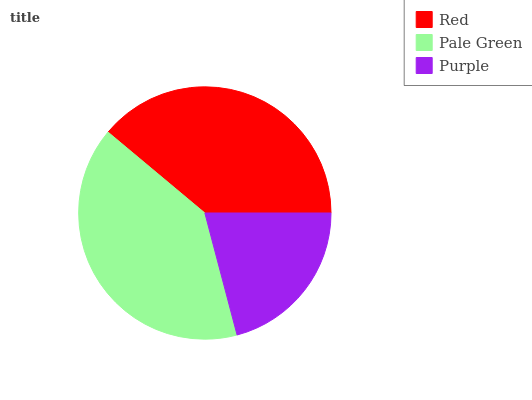Is Purple the minimum?
Answer yes or no. Yes. Is Pale Green the maximum?
Answer yes or no. Yes. Is Pale Green the minimum?
Answer yes or no. No. Is Purple the maximum?
Answer yes or no. No. Is Pale Green greater than Purple?
Answer yes or no. Yes. Is Purple less than Pale Green?
Answer yes or no. Yes. Is Purple greater than Pale Green?
Answer yes or no. No. Is Pale Green less than Purple?
Answer yes or no. No. Is Red the high median?
Answer yes or no. Yes. Is Red the low median?
Answer yes or no. Yes. Is Pale Green the high median?
Answer yes or no. No. Is Purple the low median?
Answer yes or no. No. 